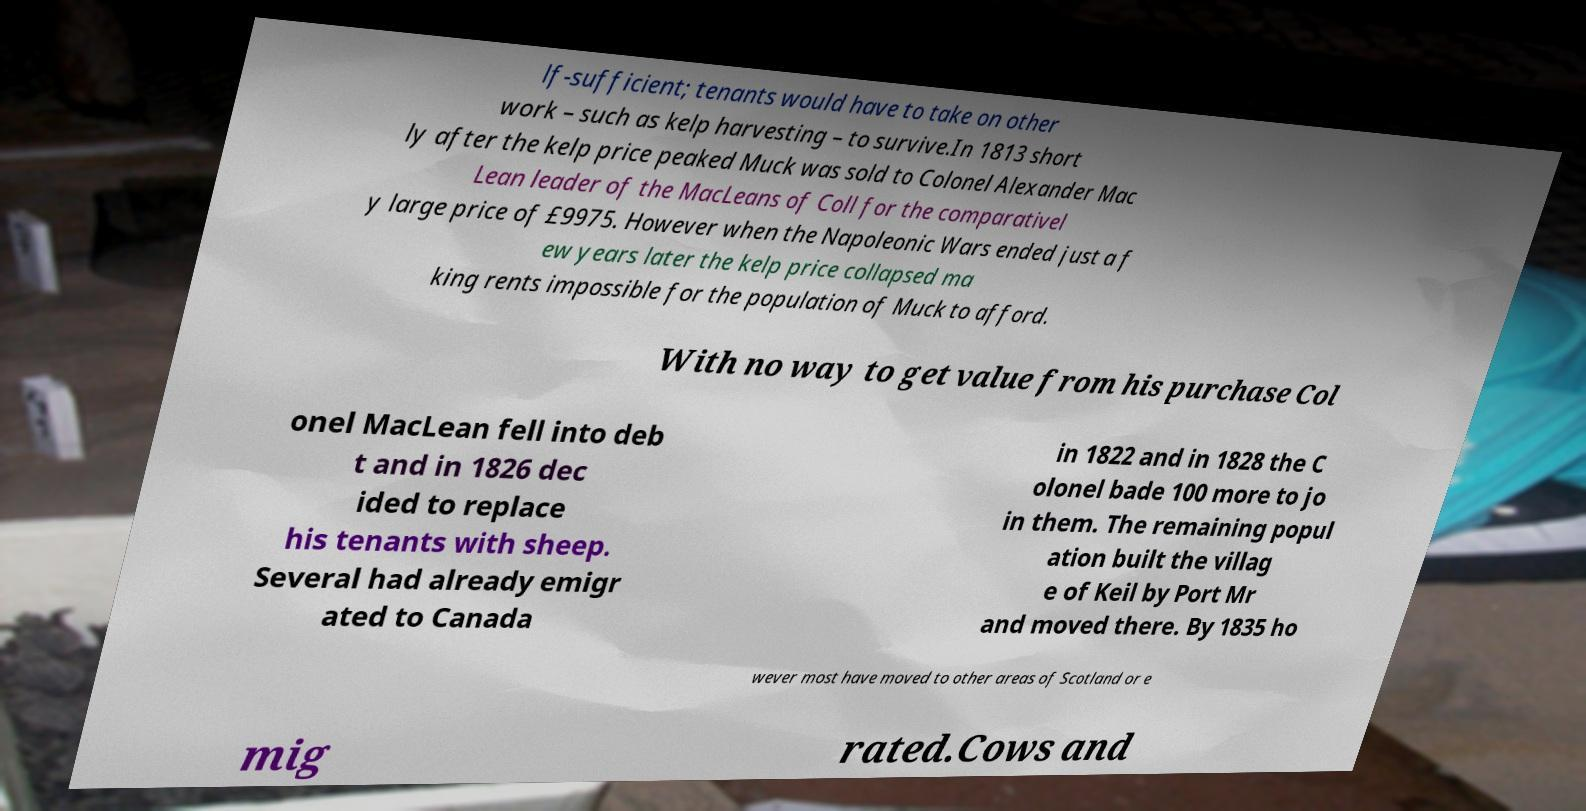Please identify and transcribe the text found in this image. lf-sufficient; tenants would have to take on other work – such as kelp harvesting – to survive.In 1813 short ly after the kelp price peaked Muck was sold to Colonel Alexander Mac Lean leader of the MacLeans of Coll for the comparativel y large price of £9975. However when the Napoleonic Wars ended just a f ew years later the kelp price collapsed ma king rents impossible for the population of Muck to afford. With no way to get value from his purchase Col onel MacLean fell into deb t and in 1826 dec ided to replace his tenants with sheep. Several had already emigr ated to Canada in 1822 and in 1828 the C olonel bade 100 more to jo in them. The remaining popul ation built the villag e of Keil by Port Mr and moved there. By 1835 ho wever most have moved to other areas of Scotland or e mig rated.Cows and 